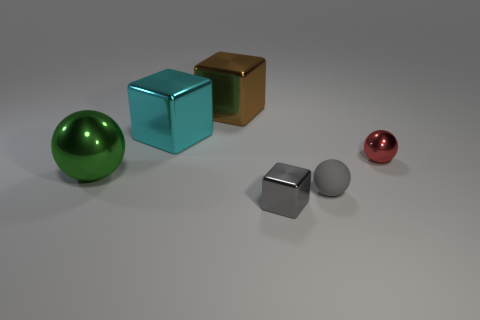What is the size of the metal thing that is the same color as the small matte thing? The metal object that shares the same silver color as the small matte cube appears to be mid-sized when compared to the other objects in the image, suggesting it may be small to medium in size in relation to the cubes. 